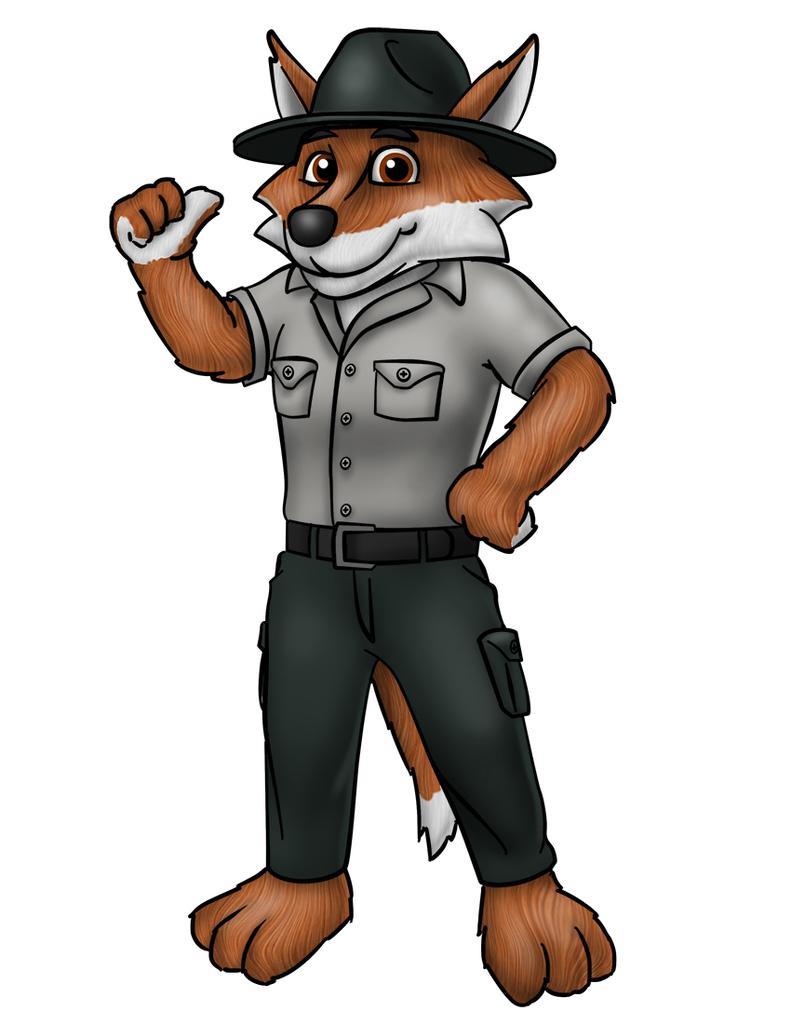In one or two sentences, can you explain what this image depicts? It is an animated image, a fox is standing, it wore shirt, trouser, belt and a hat. 